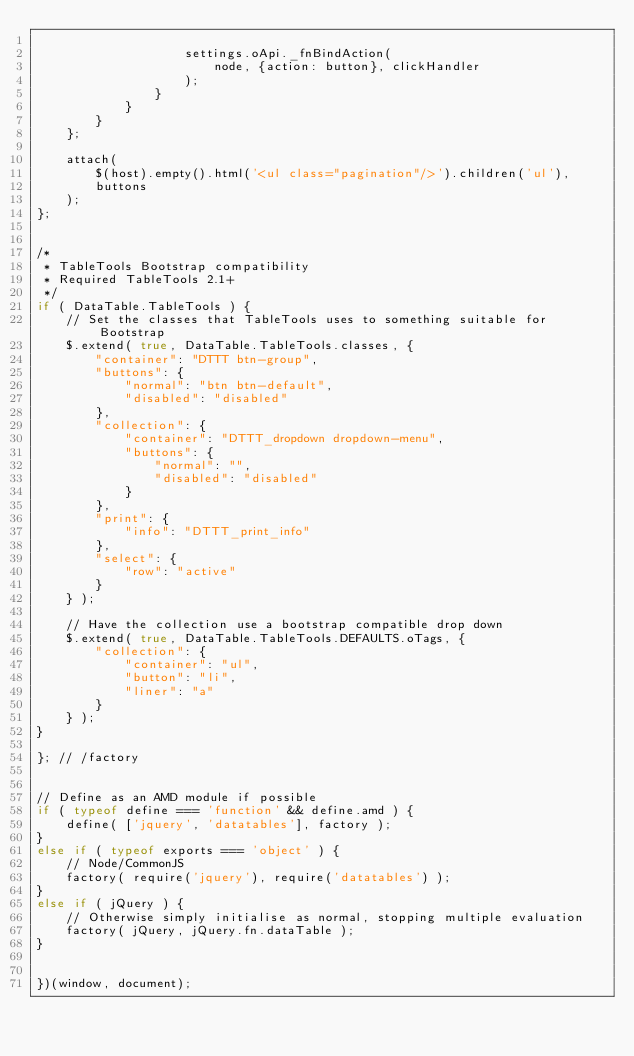Convert code to text. <code><loc_0><loc_0><loc_500><loc_500><_JavaScript_>
					settings.oApi._fnBindAction(
						node, {action: button}, clickHandler
					);
				}
			}
		}
	};

	attach(
		$(host).empty().html('<ul class="pagination"/>').children('ul'),
		buttons
	);
};


/*
 * TableTools Bootstrap compatibility
 * Required TableTools 2.1+
 */
if ( DataTable.TableTools ) {
	// Set the classes that TableTools uses to something suitable for Bootstrap
	$.extend( true, DataTable.TableTools.classes, {
		"container": "DTTT btn-group",
		"buttons": {
			"normal": "btn btn-default",
			"disabled": "disabled"
		},
		"collection": {
			"container": "DTTT_dropdown dropdown-menu",
			"buttons": {
				"normal": "",
				"disabled": "disabled"
			}
		},
		"print": {
			"info": "DTTT_print_info"
		},
		"select": {
			"row": "active"
		}
	} );

	// Have the collection use a bootstrap compatible drop down
	$.extend( true, DataTable.TableTools.DEFAULTS.oTags, {
		"collection": {
			"container": "ul",
			"button": "li",
			"liner": "a"
		}
	} );
}

}; // /factory


// Define as an AMD module if possible
if ( typeof define === 'function' && define.amd ) {
	define( ['jquery', 'datatables'], factory );
}
else if ( typeof exports === 'object' ) {
    // Node/CommonJS
    factory( require('jquery'), require('datatables') );
}
else if ( jQuery ) {
	// Otherwise simply initialise as normal, stopping multiple evaluation
	factory( jQuery, jQuery.fn.dataTable );
}


})(window, document);

</code> 